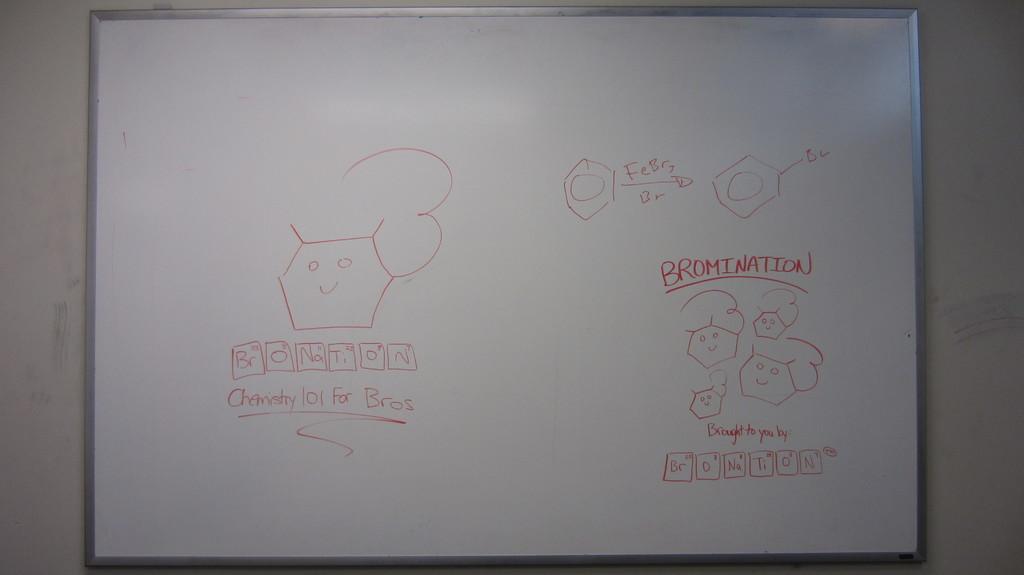What did they draw on the board?
Offer a very short reply. Bromination. What is written on the board?
Keep it short and to the point. Bromination. 